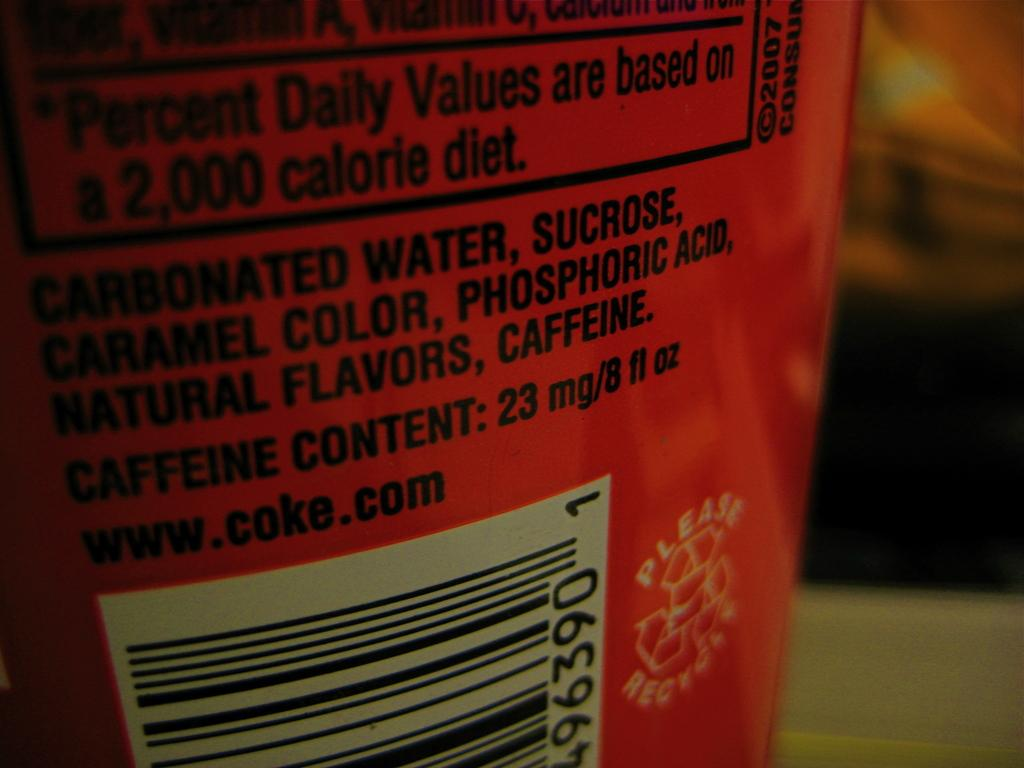Provide a one-sentence caption for the provided image. an item with the word caffeine on the back. 